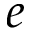<formula> <loc_0><loc_0><loc_500><loc_500>e</formula> 